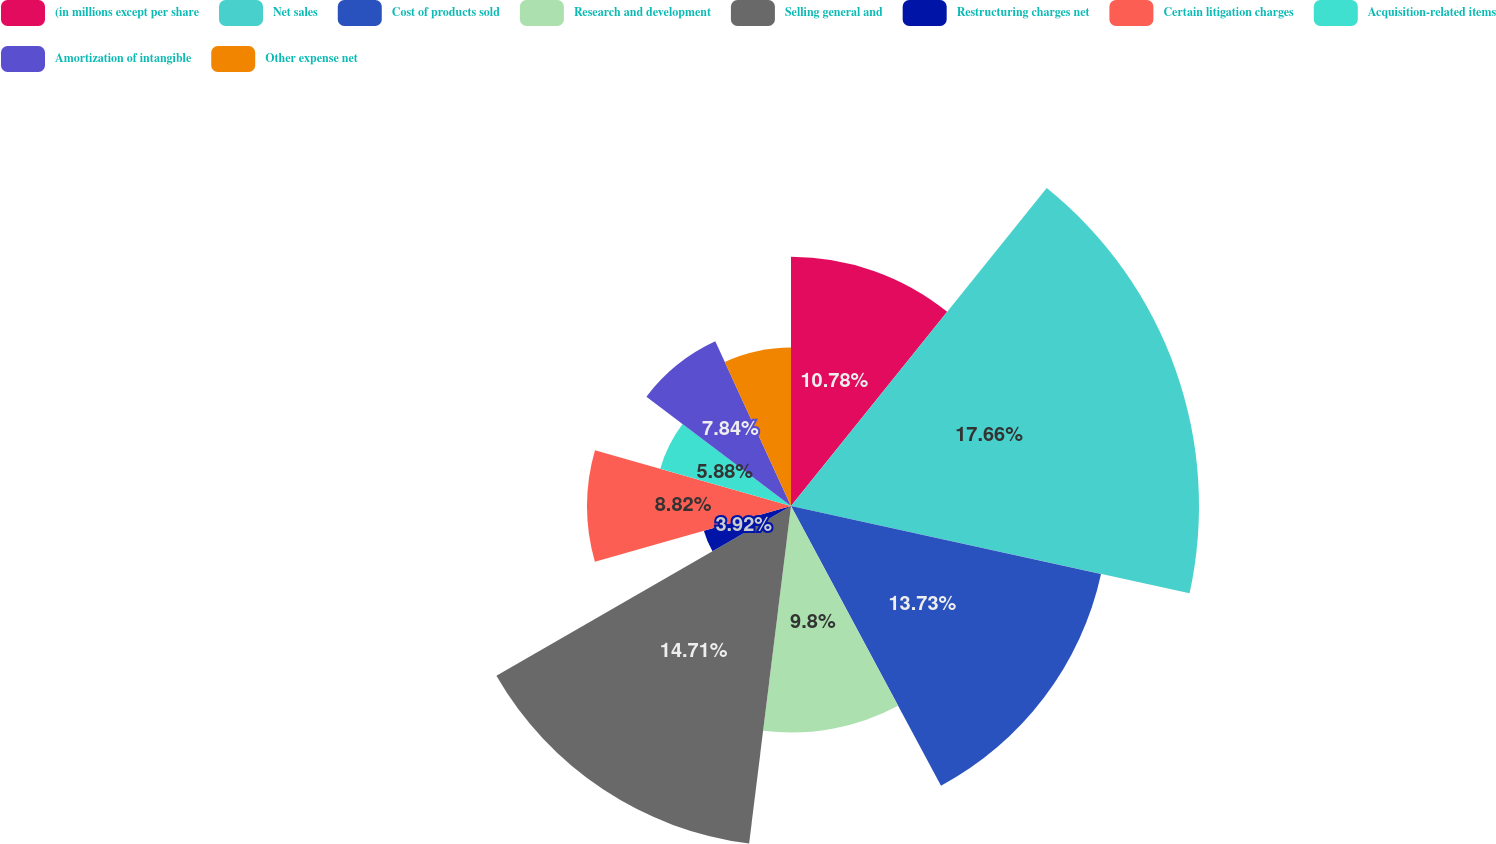Convert chart. <chart><loc_0><loc_0><loc_500><loc_500><pie_chart><fcel>(in millions except per share<fcel>Net sales<fcel>Cost of products sold<fcel>Research and development<fcel>Selling general and<fcel>Restructuring charges net<fcel>Certain litigation charges<fcel>Acquisition-related items<fcel>Amortization of intangible<fcel>Other expense net<nl><fcel>10.78%<fcel>17.65%<fcel>13.73%<fcel>9.8%<fcel>14.71%<fcel>3.92%<fcel>8.82%<fcel>5.88%<fcel>7.84%<fcel>6.86%<nl></chart> 